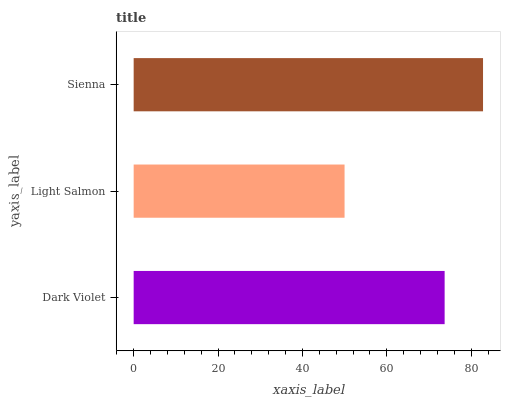Is Light Salmon the minimum?
Answer yes or no. Yes. Is Sienna the maximum?
Answer yes or no. Yes. Is Sienna the minimum?
Answer yes or no. No. Is Light Salmon the maximum?
Answer yes or no. No. Is Sienna greater than Light Salmon?
Answer yes or no. Yes. Is Light Salmon less than Sienna?
Answer yes or no. Yes. Is Light Salmon greater than Sienna?
Answer yes or no. No. Is Sienna less than Light Salmon?
Answer yes or no. No. Is Dark Violet the high median?
Answer yes or no. Yes. Is Dark Violet the low median?
Answer yes or no. Yes. Is Light Salmon the high median?
Answer yes or no. No. Is Sienna the low median?
Answer yes or no. No. 